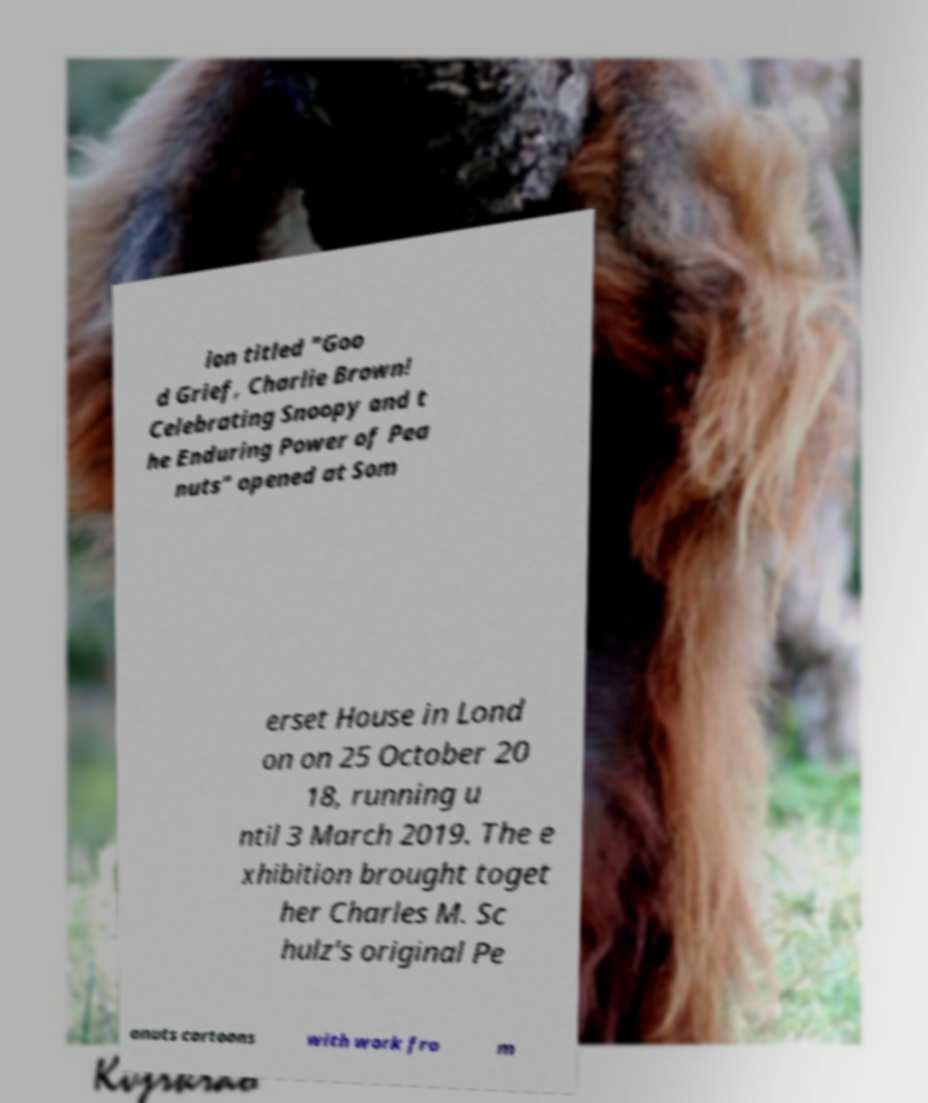Can you accurately transcribe the text from the provided image for me? ion titled "Goo d Grief, Charlie Brown! Celebrating Snoopy and t he Enduring Power of Pea nuts" opened at Som erset House in Lond on on 25 October 20 18, running u ntil 3 March 2019. The e xhibition brought toget her Charles M. Sc hulz's original Pe anuts cartoons with work fro m 